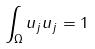Convert formula to latex. <formula><loc_0><loc_0><loc_500><loc_500>\int _ { \Omega } u _ { j } u _ { j } = 1</formula> 